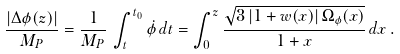<formula> <loc_0><loc_0><loc_500><loc_500>\frac { | \Delta \phi ( z ) | } { M _ { P } } = \frac { 1 } { M _ { P } } \, \int _ { t } ^ { t _ { 0 } } { \dot { \phi } \, d t } = \int _ { 0 } ^ { z } { \frac { \sqrt { 3 \, | 1 + w ( x ) | \, \Omega _ { \phi } ( x ) } } { 1 + x } } \, d x \, .</formula> 